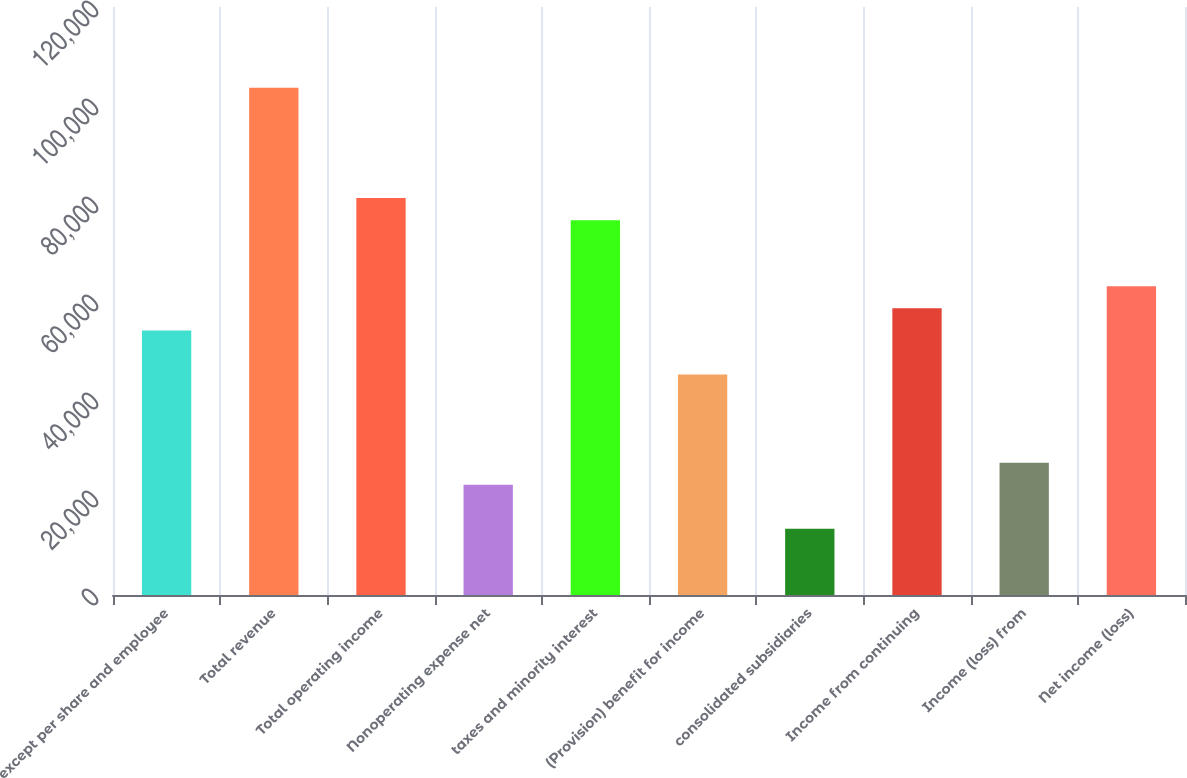Convert chart. <chart><loc_0><loc_0><loc_500><loc_500><bar_chart><fcel>except per share and employee<fcel>Total revenue<fcel>Total operating income<fcel>Nonoperating expense net<fcel>taxes and minority interest<fcel>(Provision) benefit for income<fcel>consolidated subsidiaries<fcel>Income from continuing<fcel>Income (loss) from<fcel>Net income (loss)<nl><fcel>53999.9<fcel>103500<fcel>80999.8<fcel>22500.2<fcel>76499.8<fcel>45000<fcel>13500.2<fcel>58499.9<fcel>27000.1<fcel>62999.9<nl></chart> 